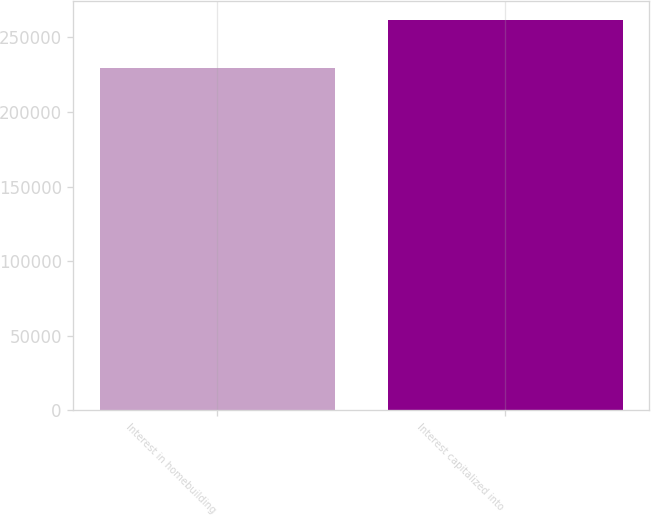Convert chart. <chart><loc_0><loc_0><loc_500><loc_500><bar_chart><fcel>Interest in homebuilding<fcel>Interest capitalized into<nl><fcel>229798<fcel>261486<nl></chart> 